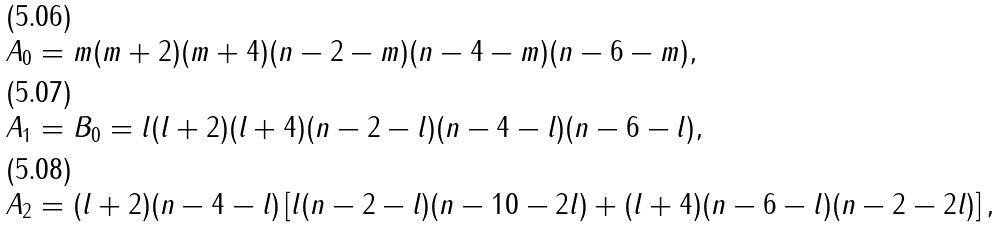<formula> <loc_0><loc_0><loc_500><loc_500>& A _ { 0 } = m ( m + 2 ) ( m + 4 ) ( n - 2 - m ) ( n - 4 - m ) ( n - 6 - m ) , \\ & A _ { 1 } = B _ { 0 } = l ( l + 2 ) ( l + 4 ) ( n - 2 - l ) ( n - 4 - l ) ( n - 6 - l ) , \\ & A _ { 2 } = ( l + 2 ) ( n - 4 - l ) \left [ l ( n - 2 - l ) ( n - 1 0 - 2 l ) + ( l + 4 ) ( n - 6 - l ) ( n - 2 - 2 l ) \right ] ,</formula> 